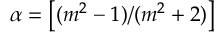<formula> <loc_0><loc_0><loc_500><loc_500>\alpha = \left [ ( m ^ { 2 } - 1 ) / ( m ^ { 2 } + 2 ) \right ]</formula> 